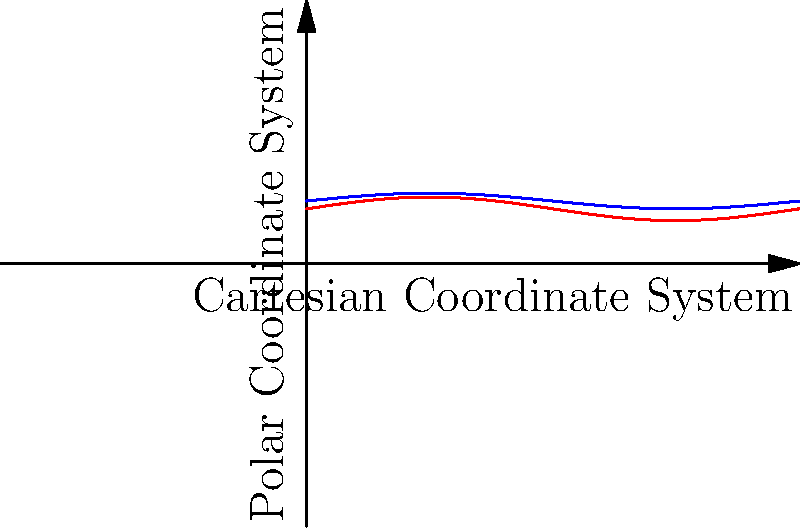Based on the graph comparing the efficiency of robotic assembly lines using Cartesian vs. polar coordinate systems over a production cycle, which system appears to be more efficient overall for traditional manufacturing processes? To determine which coordinate system is more efficient for traditional manufacturing processes, we need to analyze the graph:

1. The blue line represents the Cartesian coordinate system, while the red line represents the polar coordinate system.

2. Efficiency is plotted on the vertical axis, with higher values indicating greater efficiency.

3. The production cycle is represented on the horizontal axis, covering a full cycle (0 to 2π).

4. Observe that the Cartesian system (blue line) consistently maintains a higher position on the graph compared to the polar system (red line).

5. The Cartesian system's efficiency ranges approximately from 0.7 to 0.9, while the polar system's efficiency ranges from about 0.55 to 0.85.

6. Although both systems show some fluctuation over the production cycle, the Cartesian system's lowest point is still higher than most of the polar system's range.

7. For traditional manufacturing processes, consistency and overall higher efficiency are typically preferred.

Given these observations, the Cartesian coordinate system appears to be more efficient overall for traditional manufacturing processes in robotic assembly lines.
Answer: Cartesian coordinate system 